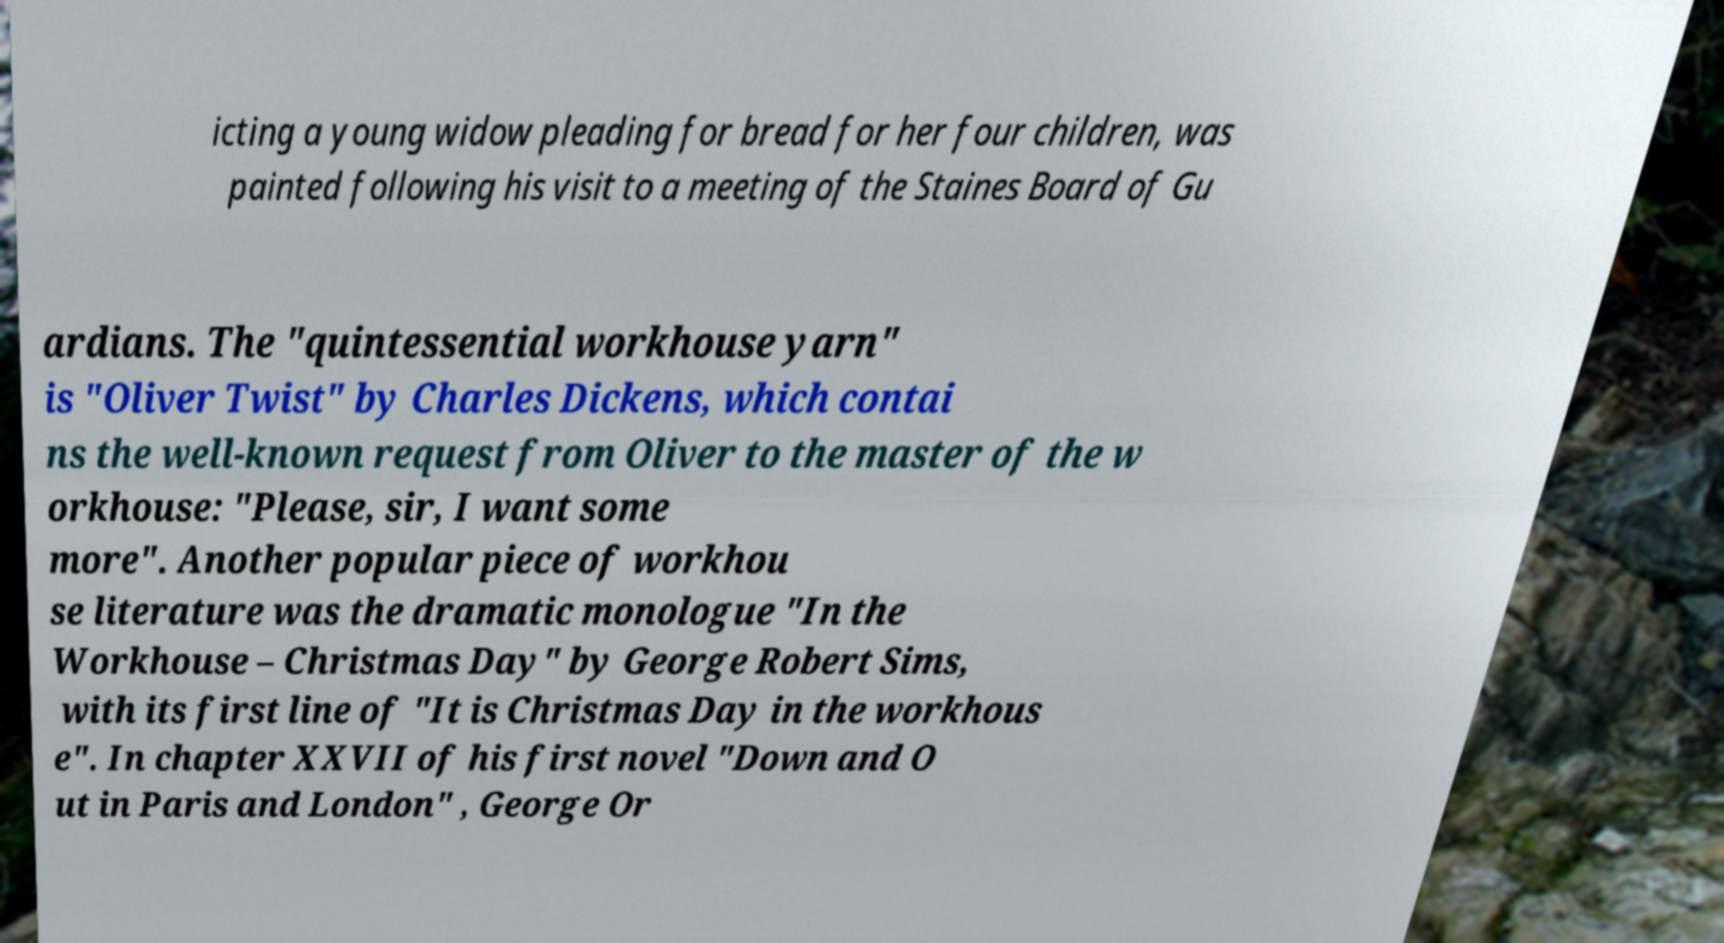I need the written content from this picture converted into text. Can you do that? icting a young widow pleading for bread for her four children, was painted following his visit to a meeting of the Staines Board of Gu ardians. The "quintessential workhouse yarn" is "Oliver Twist" by Charles Dickens, which contai ns the well-known request from Oliver to the master of the w orkhouse: "Please, sir, I want some more". Another popular piece of workhou se literature was the dramatic monologue "In the Workhouse – Christmas Day" by George Robert Sims, with its first line of "It is Christmas Day in the workhous e". In chapter XXVII of his first novel "Down and O ut in Paris and London" , George Or 